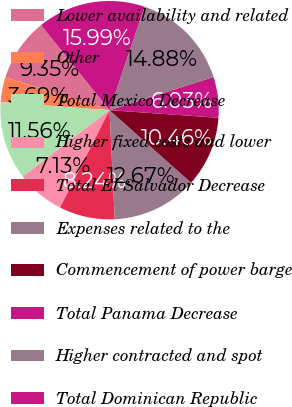<chart> <loc_0><loc_0><loc_500><loc_500><pie_chart><fcel>Lower availability and related<fcel>Other<fcel>Total Mexico Decrease<fcel>Higher fixed costs and lower<fcel>Total El Salvador Decrease<fcel>Expenses related to the<fcel>Commencement of power barge<fcel>Total Panama Decrease<fcel>Higher contracted and spot<fcel>Total Dominican Republic<nl><fcel>9.35%<fcel>3.69%<fcel>11.56%<fcel>7.13%<fcel>8.24%<fcel>12.67%<fcel>10.46%<fcel>6.03%<fcel>14.88%<fcel>15.99%<nl></chart> 